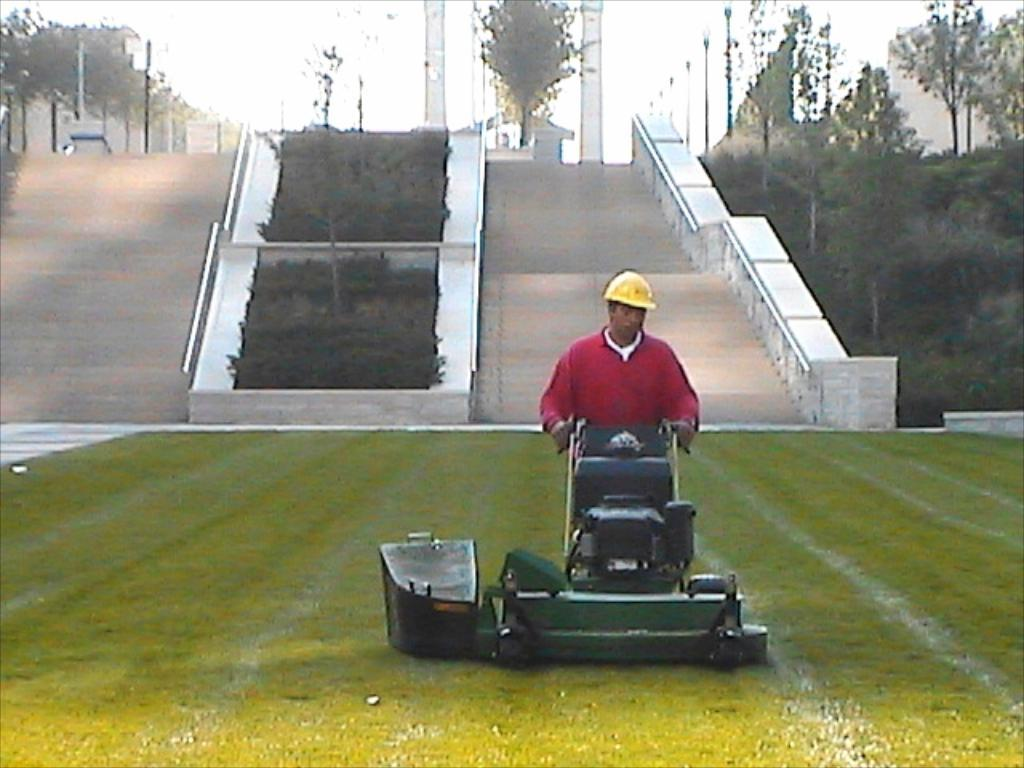Who is present in the image? There is a man in the image. What is the man holding in the image? The man is holding a grass cutting machine. What can be seen in the background of the image? There are trees and stairs in the image. Can you describe the man's attire in the image? The man is wearing a cap in the image. How would you describe the weather in the image? The sky is cloudy in the image. What type of honey is the man tasting in the image? A: There is no honey present in the image; the man is holding a grass cutting machine. How does the man express disgust in the image? There is no indication of disgust in the image; the man is simply holding a grass cutting machine. 